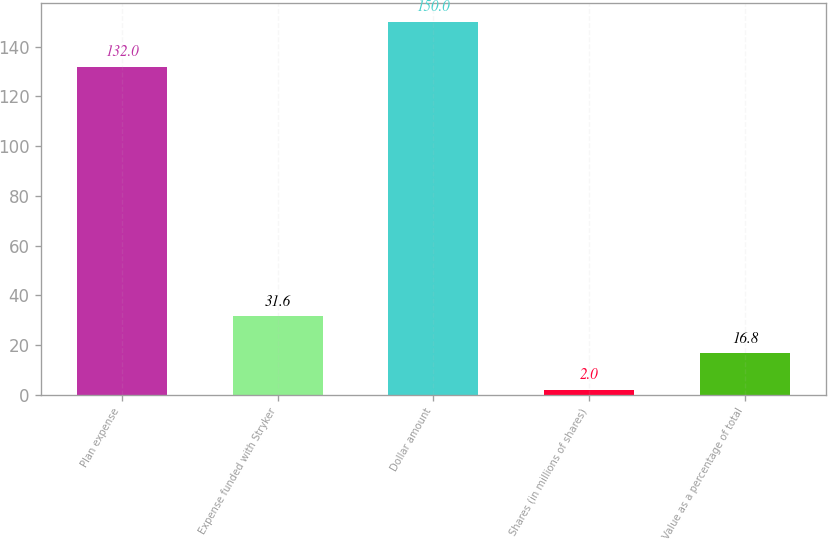<chart> <loc_0><loc_0><loc_500><loc_500><bar_chart><fcel>Plan expense<fcel>Expense funded with Stryker<fcel>Dollar amount<fcel>Shares (in millions of shares)<fcel>Value as a percentage of total<nl><fcel>132<fcel>31.6<fcel>150<fcel>2<fcel>16.8<nl></chart> 